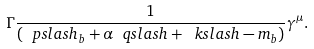Convert formula to latex. <formula><loc_0><loc_0><loc_500><loc_500>\Gamma \frac { 1 } { ( \ p s l a s h _ { b } + \alpha \ q s l a s h + \ k s l a s h - m _ { b } ) } \gamma ^ { \mu } .</formula> 